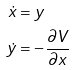Convert formula to latex. <formula><loc_0><loc_0><loc_500><loc_500>\dot { x } & = y \\ \dot { y } & = - \frac { \partial V } { \partial x }</formula> 